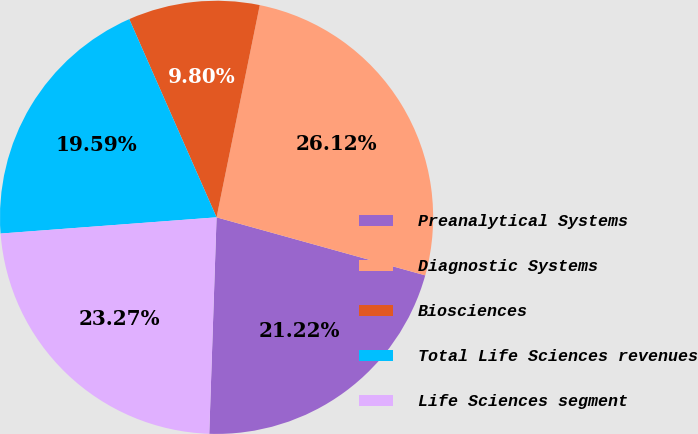<chart> <loc_0><loc_0><loc_500><loc_500><pie_chart><fcel>Preanalytical Systems<fcel>Diagnostic Systems<fcel>Biosciences<fcel>Total Life Sciences revenues<fcel>Life Sciences segment<nl><fcel>21.22%<fcel>26.12%<fcel>9.8%<fcel>19.59%<fcel>23.27%<nl></chart> 